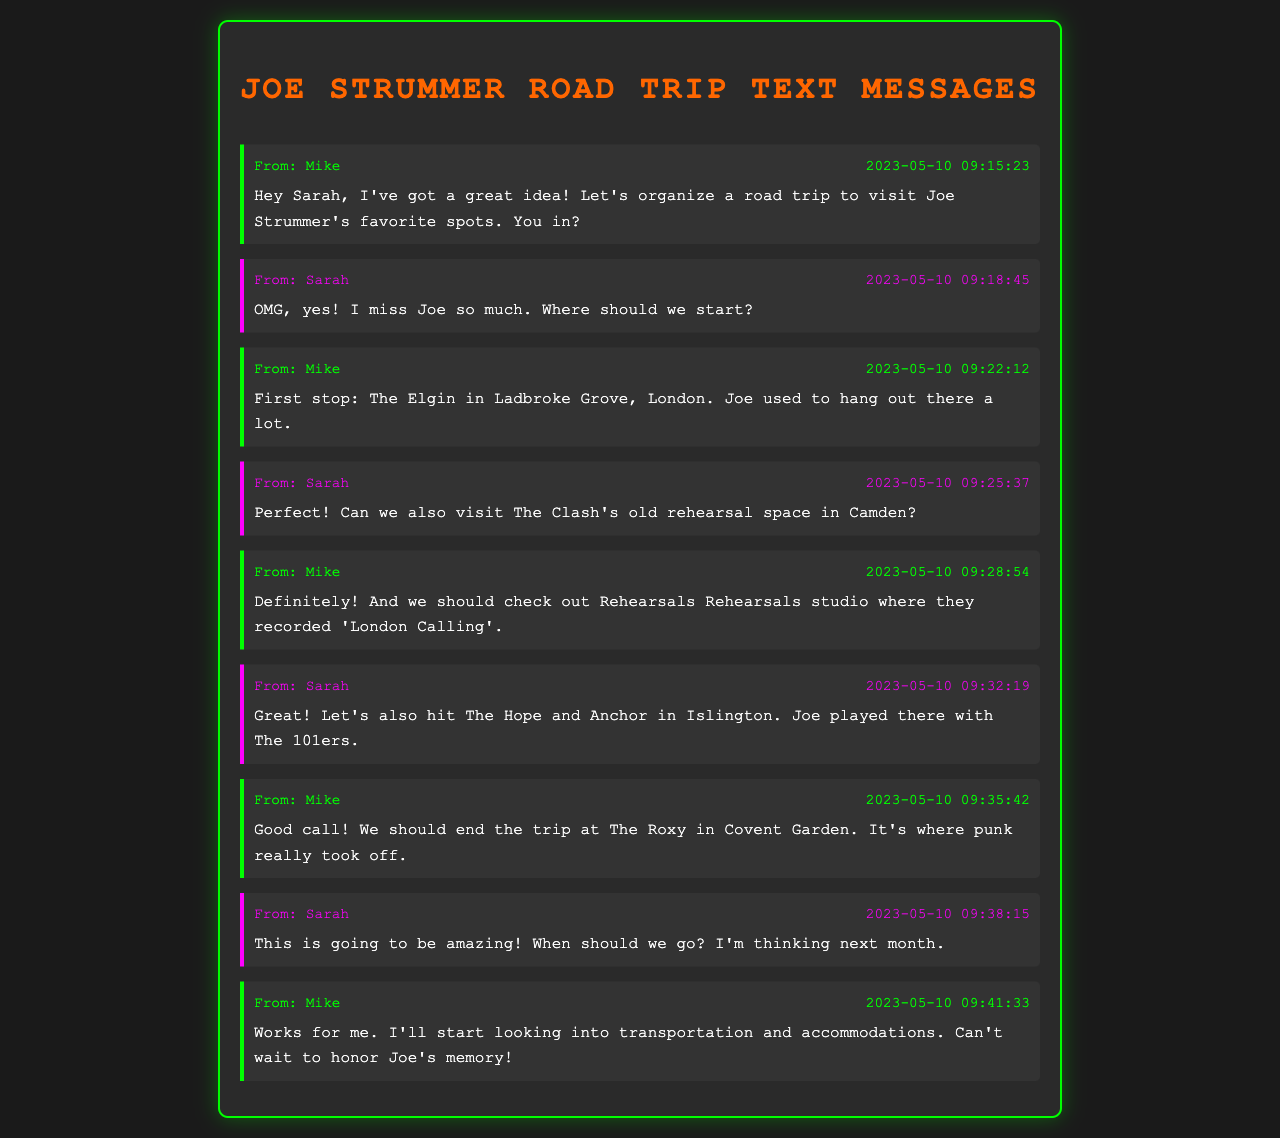what is the first message date? The first message date in the document is the timestamp for the first text sent by Mike to Sarah.
Answer: 2023-05-10 09:15:23 who is the first person to suggest the road trip? The first person to suggest organizing the road trip in the messages is Mike.
Answer: Mike what is the last pub mentioned in the messages? The last pub mentioned in the messages is The Roxy located in Covent Garden.
Answer: The Roxy how many messages are sent by Sarah? The total messages sent by Sarah can be counted in the document, which is five times.
Answer: 5 what was Joe Strummer associated with at The Hope and Anchor? The message from Sarah states that Joe played there with The 101ers.
Answer: The 101ers when is the road trip likely to happen? The suggested time for the road trip according to the final message is next month.
Answer: next month 